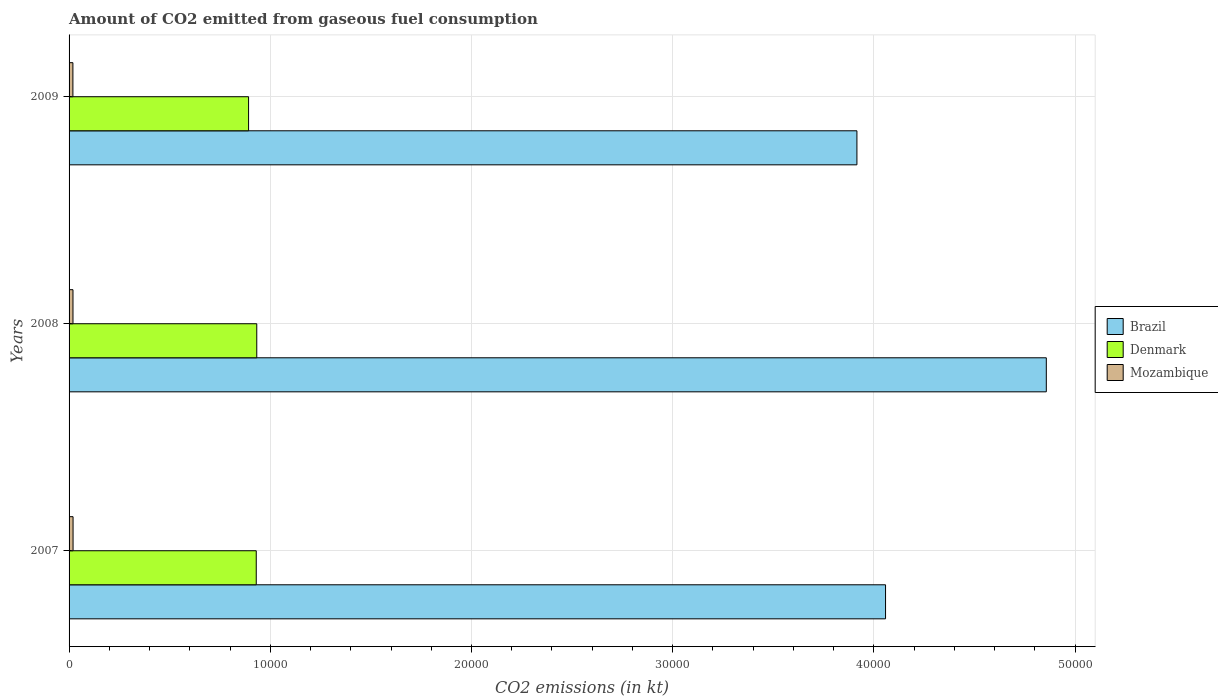How many different coloured bars are there?
Give a very brief answer. 3. How many groups of bars are there?
Make the answer very short. 3. Are the number of bars per tick equal to the number of legend labels?
Offer a terse response. Yes. Are the number of bars on each tick of the Y-axis equal?
Provide a succinct answer. Yes. How many bars are there on the 1st tick from the top?
Provide a short and direct response. 3. How many bars are there on the 3rd tick from the bottom?
Provide a succinct answer. 3. What is the label of the 1st group of bars from the top?
Provide a succinct answer. 2009. In how many cases, is the number of bars for a given year not equal to the number of legend labels?
Keep it short and to the point. 0. What is the amount of CO2 emitted in Denmark in 2009?
Keep it short and to the point. 8921.81. Across all years, what is the maximum amount of CO2 emitted in Denmark?
Offer a very short reply. 9328.85. Across all years, what is the minimum amount of CO2 emitted in Denmark?
Ensure brevity in your answer.  8921.81. In which year was the amount of CO2 emitted in Brazil minimum?
Your response must be concise. 2009. What is the total amount of CO2 emitted in Denmark in the graph?
Provide a short and direct response. 2.76e+04. What is the difference between the amount of CO2 emitted in Brazil in 2008 and that in 2009?
Your response must be concise. 9413.19. What is the difference between the amount of CO2 emitted in Brazil in 2009 and the amount of CO2 emitted in Mozambique in 2008?
Your response must be concise. 3.90e+04. What is the average amount of CO2 emitted in Denmark per year?
Ensure brevity in your answer.  9184.61. In the year 2007, what is the difference between the amount of CO2 emitted in Denmark and amount of CO2 emitted in Mozambique?
Ensure brevity in your answer.  9105.16. In how many years, is the amount of CO2 emitted in Denmark greater than 4000 kt?
Offer a very short reply. 3. What is the ratio of the amount of CO2 emitted in Mozambique in 2008 to that in 2009?
Offer a very short reply. 1.02. Is the amount of CO2 emitted in Denmark in 2007 less than that in 2009?
Ensure brevity in your answer.  No. What is the difference between the highest and the second highest amount of CO2 emitted in Brazil?
Offer a terse response. 7990.39. What is the difference between the highest and the lowest amount of CO2 emitted in Brazil?
Make the answer very short. 9413.19. In how many years, is the amount of CO2 emitted in Brazil greater than the average amount of CO2 emitted in Brazil taken over all years?
Keep it short and to the point. 1. Is the sum of the amount of CO2 emitted in Brazil in 2007 and 2009 greater than the maximum amount of CO2 emitted in Mozambique across all years?
Offer a terse response. Yes. What does the 1st bar from the top in 2007 represents?
Provide a succinct answer. Mozambique. Is it the case that in every year, the sum of the amount of CO2 emitted in Brazil and amount of CO2 emitted in Denmark is greater than the amount of CO2 emitted in Mozambique?
Offer a terse response. Yes. How many bars are there?
Keep it short and to the point. 9. Does the graph contain grids?
Your response must be concise. Yes. How many legend labels are there?
Your response must be concise. 3. How are the legend labels stacked?
Offer a very short reply. Vertical. What is the title of the graph?
Your response must be concise. Amount of CO2 emitted from gaseous fuel consumption. What is the label or title of the X-axis?
Your answer should be compact. CO2 emissions (in kt). What is the label or title of the Y-axis?
Keep it short and to the point. Years. What is the CO2 emissions (in kt) of Brazil in 2007?
Offer a terse response. 4.06e+04. What is the CO2 emissions (in kt) of Denmark in 2007?
Give a very brief answer. 9303.18. What is the CO2 emissions (in kt) of Mozambique in 2007?
Your answer should be very brief. 198.02. What is the CO2 emissions (in kt) in Brazil in 2008?
Keep it short and to the point. 4.86e+04. What is the CO2 emissions (in kt) of Denmark in 2008?
Keep it short and to the point. 9328.85. What is the CO2 emissions (in kt) of Mozambique in 2008?
Keep it short and to the point. 194.35. What is the CO2 emissions (in kt) in Brazil in 2009?
Offer a terse response. 3.92e+04. What is the CO2 emissions (in kt) in Denmark in 2009?
Your answer should be compact. 8921.81. What is the CO2 emissions (in kt) of Mozambique in 2009?
Your response must be concise. 190.68. Across all years, what is the maximum CO2 emissions (in kt) in Brazil?
Make the answer very short. 4.86e+04. Across all years, what is the maximum CO2 emissions (in kt) in Denmark?
Offer a terse response. 9328.85. Across all years, what is the maximum CO2 emissions (in kt) in Mozambique?
Your response must be concise. 198.02. Across all years, what is the minimum CO2 emissions (in kt) of Brazil?
Offer a very short reply. 3.92e+04. Across all years, what is the minimum CO2 emissions (in kt) in Denmark?
Your response must be concise. 8921.81. Across all years, what is the minimum CO2 emissions (in kt) in Mozambique?
Offer a terse response. 190.68. What is the total CO2 emissions (in kt) of Brazil in the graph?
Your answer should be very brief. 1.28e+05. What is the total CO2 emissions (in kt) of Denmark in the graph?
Offer a terse response. 2.76e+04. What is the total CO2 emissions (in kt) in Mozambique in the graph?
Offer a very short reply. 583.05. What is the difference between the CO2 emissions (in kt) in Brazil in 2007 and that in 2008?
Offer a very short reply. -7990.39. What is the difference between the CO2 emissions (in kt) of Denmark in 2007 and that in 2008?
Your response must be concise. -25.67. What is the difference between the CO2 emissions (in kt) of Mozambique in 2007 and that in 2008?
Make the answer very short. 3.67. What is the difference between the CO2 emissions (in kt) of Brazil in 2007 and that in 2009?
Give a very brief answer. 1422.8. What is the difference between the CO2 emissions (in kt) in Denmark in 2007 and that in 2009?
Offer a very short reply. 381.37. What is the difference between the CO2 emissions (in kt) of Mozambique in 2007 and that in 2009?
Ensure brevity in your answer.  7.33. What is the difference between the CO2 emissions (in kt) in Brazil in 2008 and that in 2009?
Your response must be concise. 9413.19. What is the difference between the CO2 emissions (in kt) in Denmark in 2008 and that in 2009?
Ensure brevity in your answer.  407.04. What is the difference between the CO2 emissions (in kt) of Mozambique in 2008 and that in 2009?
Keep it short and to the point. 3.67. What is the difference between the CO2 emissions (in kt) in Brazil in 2007 and the CO2 emissions (in kt) in Denmark in 2008?
Offer a terse response. 3.13e+04. What is the difference between the CO2 emissions (in kt) in Brazil in 2007 and the CO2 emissions (in kt) in Mozambique in 2008?
Offer a very short reply. 4.04e+04. What is the difference between the CO2 emissions (in kt) of Denmark in 2007 and the CO2 emissions (in kt) of Mozambique in 2008?
Offer a terse response. 9108.83. What is the difference between the CO2 emissions (in kt) of Brazil in 2007 and the CO2 emissions (in kt) of Denmark in 2009?
Make the answer very short. 3.17e+04. What is the difference between the CO2 emissions (in kt) of Brazil in 2007 and the CO2 emissions (in kt) of Mozambique in 2009?
Provide a short and direct response. 4.04e+04. What is the difference between the CO2 emissions (in kt) in Denmark in 2007 and the CO2 emissions (in kt) in Mozambique in 2009?
Offer a very short reply. 9112.5. What is the difference between the CO2 emissions (in kt) in Brazil in 2008 and the CO2 emissions (in kt) in Denmark in 2009?
Offer a terse response. 3.96e+04. What is the difference between the CO2 emissions (in kt) in Brazil in 2008 and the CO2 emissions (in kt) in Mozambique in 2009?
Make the answer very short. 4.84e+04. What is the difference between the CO2 emissions (in kt) in Denmark in 2008 and the CO2 emissions (in kt) in Mozambique in 2009?
Ensure brevity in your answer.  9138.16. What is the average CO2 emissions (in kt) in Brazil per year?
Ensure brevity in your answer.  4.28e+04. What is the average CO2 emissions (in kt) of Denmark per year?
Your answer should be compact. 9184.61. What is the average CO2 emissions (in kt) in Mozambique per year?
Make the answer very short. 194.35. In the year 2007, what is the difference between the CO2 emissions (in kt) of Brazil and CO2 emissions (in kt) of Denmark?
Your response must be concise. 3.13e+04. In the year 2007, what is the difference between the CO2 emissions (in kt) in Brazil and CO2 emissions (in kt) in Mozambique?
Provide a short and direct response. 4.04e+04. In the year 2007, what is the difference between the CO2 emissions (in kt) of Denmark and CO2 emissions (in kt) of Mozambique?
Provide a succinct answer. 9105.16. In the year 2008, what is the difference between the CO2 emissions (in kt) of Brazil and CO2 emissions (in kt) of Denmark?
Provide a succinct answer. 3.92e+04. In the year 2008, what is the difference between the CO2 emissions (in kt) of Brazil and CO2 emissions (in kt) of Mozambique?
Keep it short and to the point. 4.84e+04. In the year 2008, what is the difference between the CO2 emissions (in kt) of Denmark and CO2 emissions (in kt) of Mozambique?
Give a very brief answer. 9134.5. In the year 2009, what is the difference between the CO2 emissions (in kt) in Brazil and CO2 emissions (in kt) in Denmark?
Offer a very short reply. 3.02e+04. In the year 2009, what is the difference between the CO2 emissions (in kt) of Brazil and CO2 emissions (in kt) of Mozambique?
Your response must be concise. 3.90e+04. In the year 2009, what is the difference between the CO2 emissions (in kt) in Denmark and CO2 emissions (in kt) in Mozambique?
Provide a succinct answer. 8731.13. What is the ratio of the CO2 emissions (in kt) in Brazil in 2007 to that in 2008?
Your answer should be compact. 0.84. What is the ratio of the CO2 emissions (in kt) in Mozambique in 2007 to that in 2008?
Offer a terse response. 1.02. What is the ratio of the CO2 emissions (in kt) of Brazil in 2007 to that in 2009?
Provide a short and direct response. 1.04. What is the ratio of the CO2 emissions (in kt) in Denmark in 2007 to that in 2009?
Give a very brief answer. 1.04. What is the ratio of the CO2 emissions (in kt) in Brazil in 2008 to that in 2009?
Provide a succinct answer. 1.24. What is the ratio of the CO2 emissions (in kt) of Denmark in 2008 to that in 2009?
Give a very brief answer. 1.05. What is the ratio of the CO2 emissions (in kt) of Mozambique in 2008 to that in 2009?
Provide a succinct answer. 1.02. What is the difference between the highest and the second highest CO2 emissions (in kt) in Brazil?
Offer a very short reply. 7990.39. What is the difference between the highest and the second highest CO2 emissions (in kt) of Denmark?
Your answer should be very brief. 25.67. What is the difference between the highest and the second highest CO2 emissions (in kt) in Mozambique?
Make the answer very short. 3.67. What is the difference between the highest and the lowest CO2 emissions (in kt) in Brazil?
Provide a succinct answer. 9413.19. What is the difference between the highest and the lowest CO2 emissions (in kt) of Denmark?
Offer a terse response. 407.04. What is the difference between the highest and the lowest CO2 emissions (in kt) of Mozambique?
Offer a terse response. 7.33. 